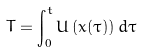<formula> <loc_0><loc_0><loc_500><loc_500>T = \int _ { 0 } ^ { t } U \left ( x ( \tau ) \right ) d \tau</formula> 